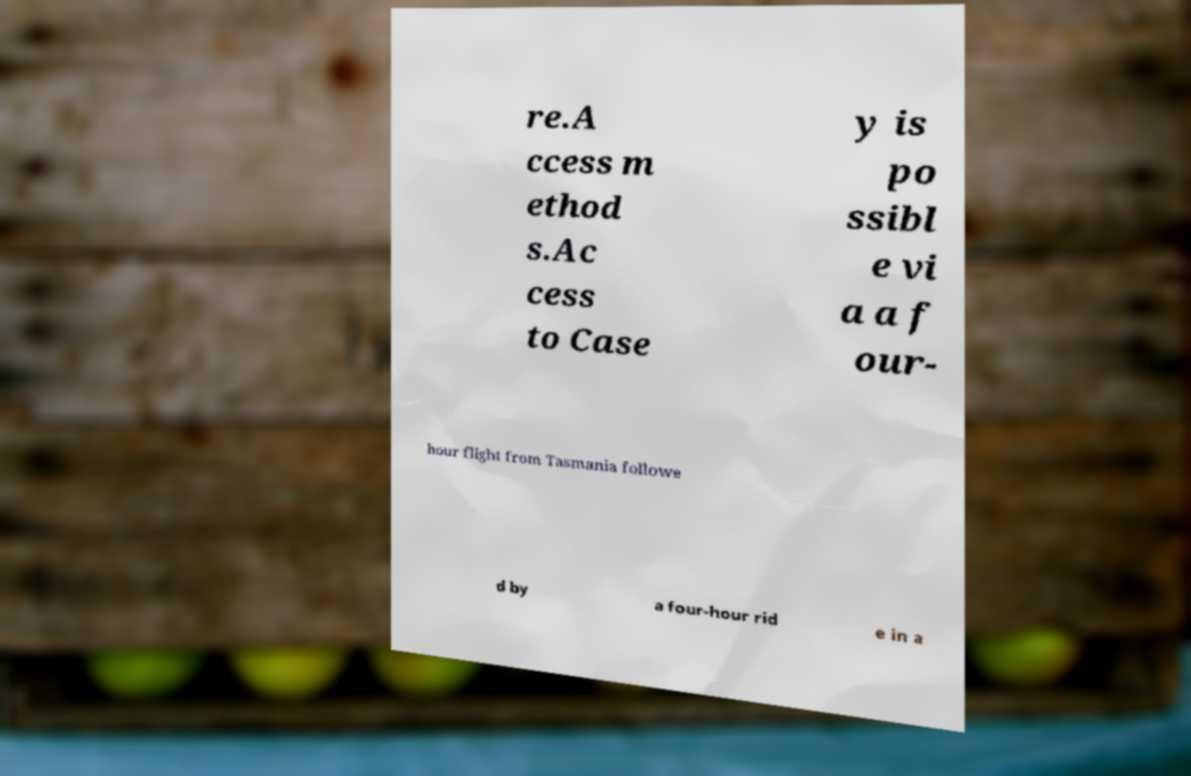What messages or text are displayed in this image? I need them in a readable, typed format. re.A ccess m ethod s.Ac cess to Case y is po ssibl e vi a a f our- hour flight from Tasmania followe d by a four-hour rid e in a 